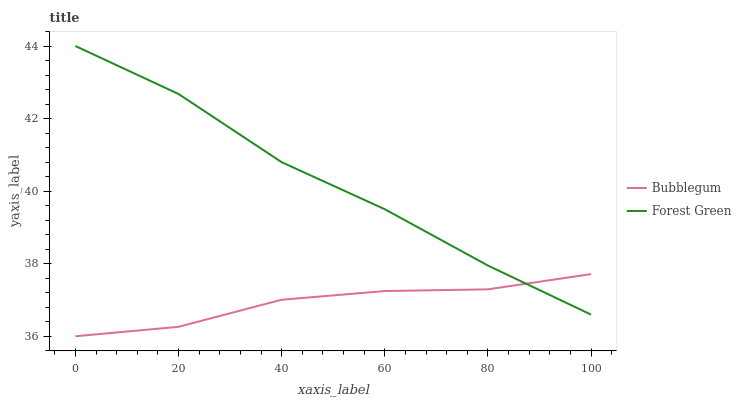Does Bubblegum have the maximum area under the curve?
Answer yes or no. No. Is Bubblegum the roughest?
Answer yes or no. No. Does Bubblegum have the highest value?
Answer yes or no. No. 